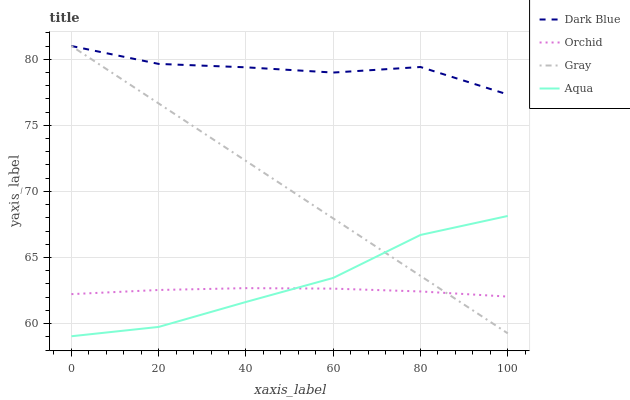Does Orchid have the minimum area under the curve?
Answer yes or no. Yes. Does Dark Blue have the maximum area under the curve?
Answer yes or no. Yes. Does Gray have the minimum area under the curve?
Answer yes or no. No. Does Gray have the maximum area under the curve?
Answer yes or no. No. Is Gray the smoothest?
Answer yes or no. Yes. Is Dark Blue the roughest?
Answer yes or no. Yes. Is Aqua the smoothest?
Answer yes or no. No. Is Aqua the roughest?
Answer yes or no. No. Does Aqua have the lowest value?
Answer yes or no. Yes. Does Gray have the lowest value?
Answer yes or no. No. Does Gray have the highest value?
Answer yes or no. Yes. Does Aqua have the highest value?
Answer yes or no. No. Is Aqua less than Dark Blue?
Answer yes or no. Yes. Is Dark Blue greater than Orchid?
Answer yes or no. Yes. Does Gray intersect Dark Blue?
Answer yes or no. Yes. Is Gray less than Dark Blue?
Answer yes or no. No. Is Gray greater than Dark Blue?
Answer yes or no. No. Does Aqua intersect Dark Blue?
Answer yes or no. No. 